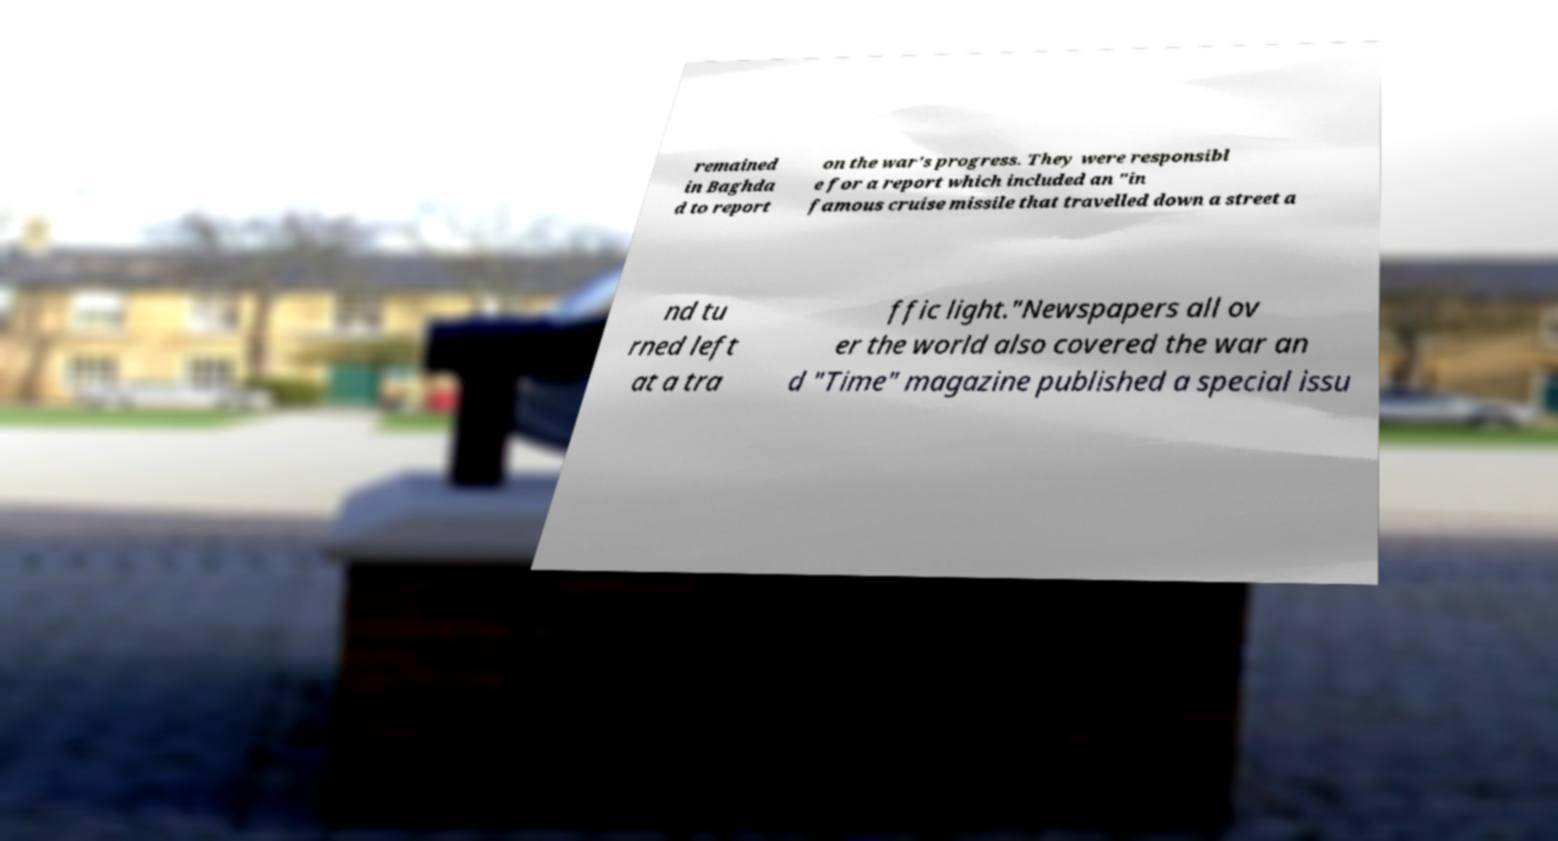Please read and relay the text visible in this image. What does it say? remained in Baghda d to report on the war's progress. They were responsibl e for a report which included an "in famous cruise missile that travelled down a street a nd tu rned left at a tra ffic light."Newspapers all ov er the world also covered the war an d "Time" magazine published a special issu 